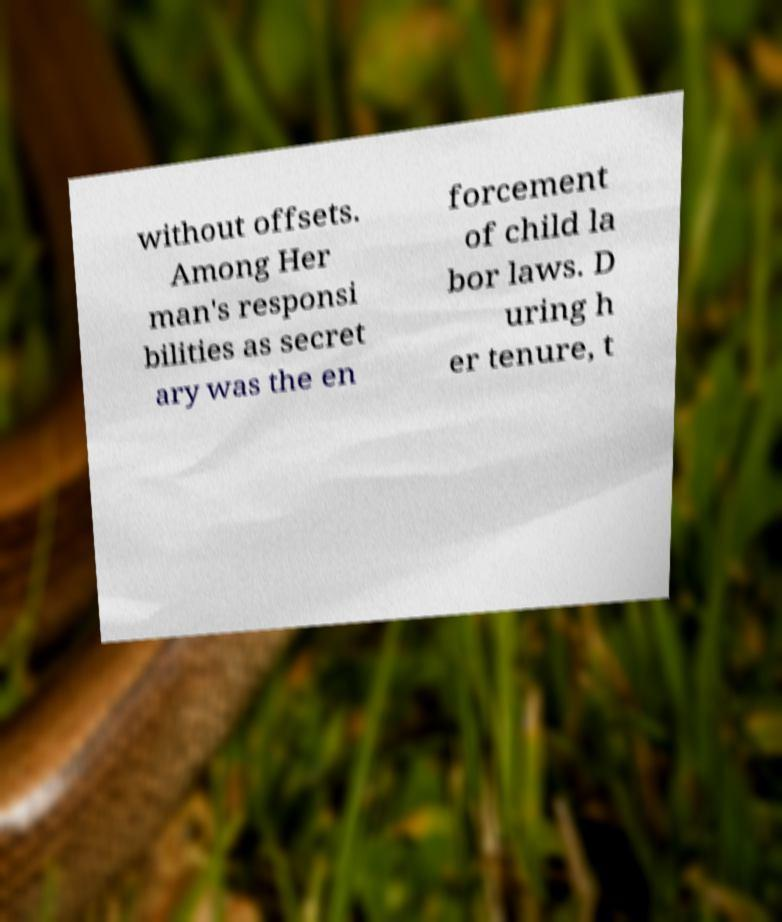Could you assist in decoding the text presented in this image and type it out clearly? without offsets. Among Her man's responsi bilities as secret ary was the en forcement of child la bor laws. D uring h er tenure, t 